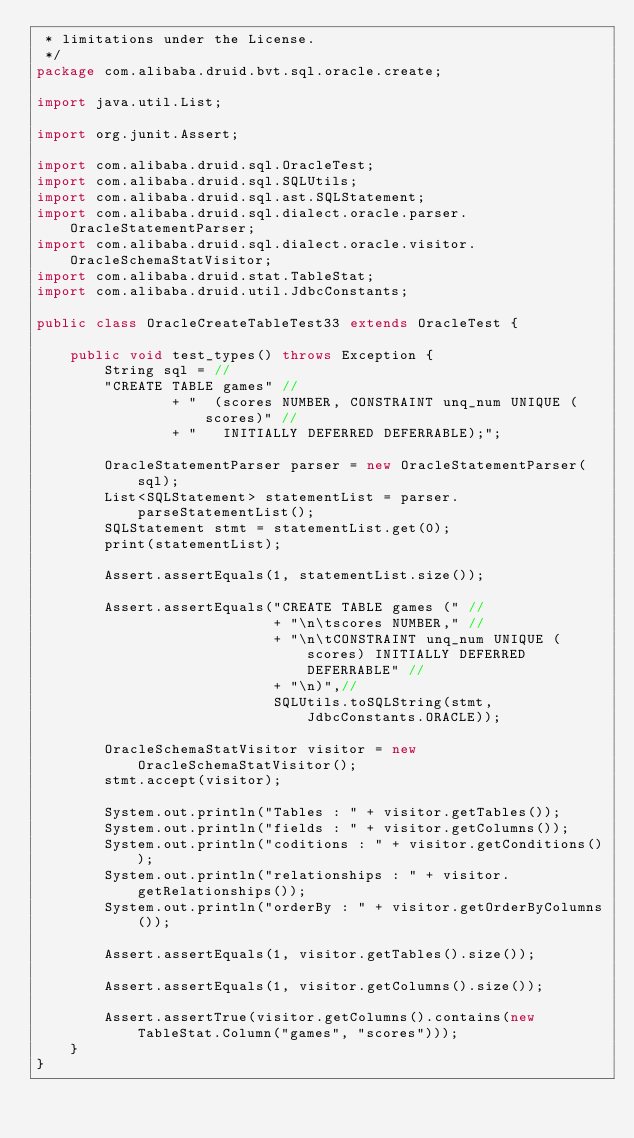<code> <loc_0><loc_0><loc_500><loc_500><_Java_> * limitations under the License.
 */
package com.alibaba.druid.bvt.sql.oracle.create;

import java.util.List;

import org.junit.Assert;

import com.alibaba.druid.sql.OracleTest;
import com.alibaba.druid.sql.SQLUtils;
import com.alibaba.druid.sql.ast.SQLStatement;
import com.alibaba.druid.sql.dialect.oracle.parser.OracleStatementParser;
import com.alibaba.druid.sql.dialect.oracle.visitor.OracleSchemaStatVisitor;
import com.alibaba.druid.stat.TableStat;
import com.alibaba.druid.util.JdbcConstants;

public class OracleCreateTableTest33 extends OracleTest {

    public void test_types() throws Exception {
        String sql = //
        "CREATE TABLE games" //
                + "  (scores NUMBER, CONSTRAINT unq_num UNIQUE (scores)" //
                + "   INITIALLY DEFERRED DEFERRABLE);";

        OracleStatementParser parser = new OracleStatementParser(sql);
        List<SQLStatement> statementList = parser.parseStatementList();
        SQLStatement stmt = statementList.get(0);
        print(statementList);

        Assert.assertEquals(1, statementList.size());

        Assert.assertEquals("CREATE TABLE games (" //
                            + "\n\tscores NUMBER," //
                            + "\n\tCONSTRAINT unq_num UNIQUE (scores) INITIALLY DEFERRED DEFERRABLE" //
                            + "\n)",//
                            SQLUtils.toSQLString(stmt, JdbcConstants.ORACLE));

        OracleSchemaStatVisitor visitor = new OracleSchemaStatVisitor();
        stmt.accept(visitor);

        System.out.println("Tables : " + visitor.getTables());
        System.out.println("fields : " + visitor.getColumns());
        System.out.println("coditions : " + visitor.getConditions());
        System.out.println("relationships : " + visitor.getRelationships());
        System.out.println("orderBy : " + visitor.getOrderByColumns());

        Assert.assertEquals(1, visitor.getTables().size());

        Assert.assertEquals(1, visitor.getColumns().size());

        Assert.assertTrue(visitor.getColumns().contains(new TableStat.Column("games", "scores")));
    }
}
</code> 